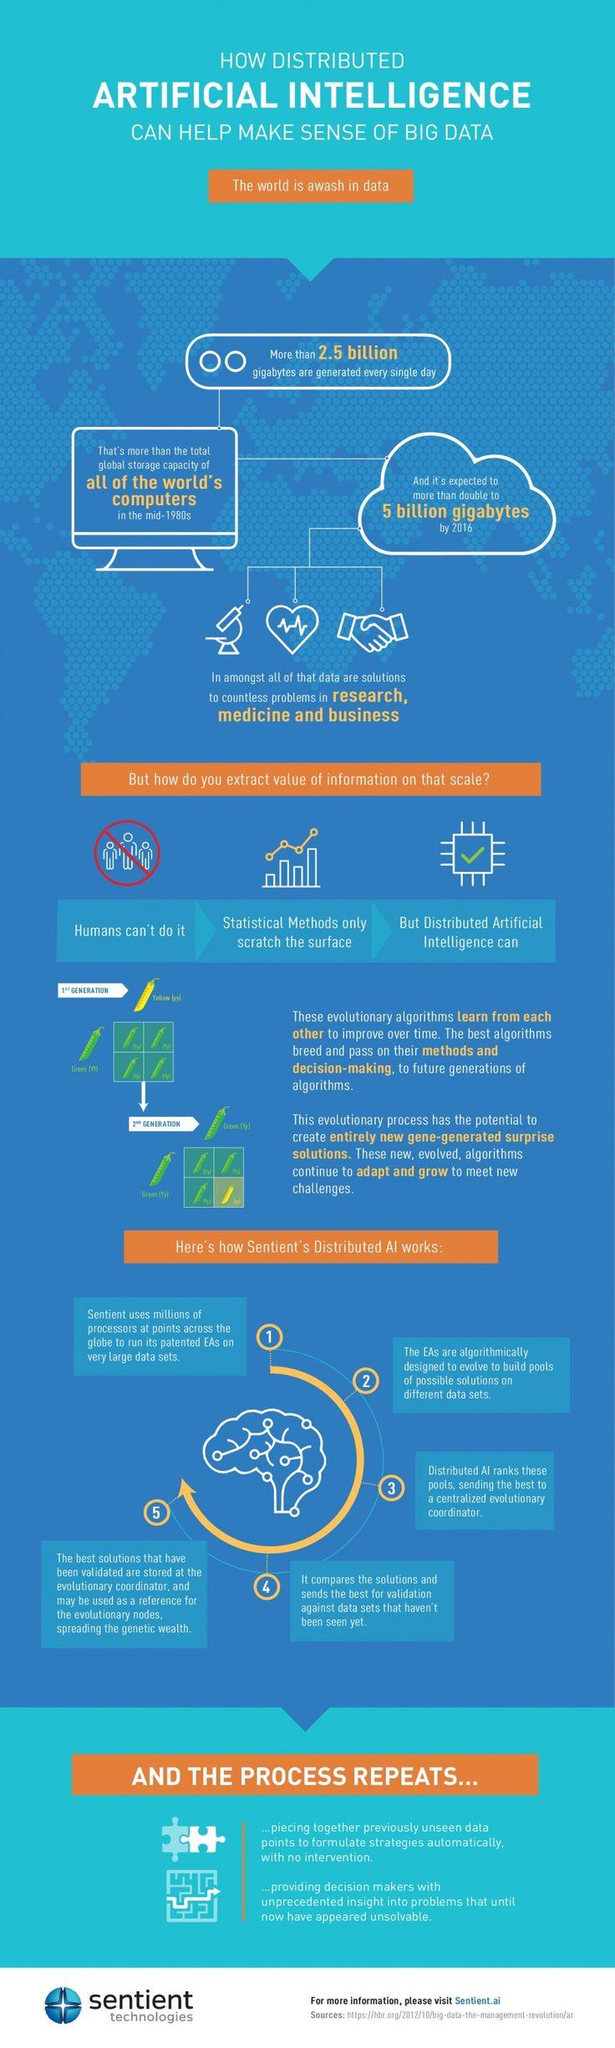Point out several critical features in this image. The most effective method for extracting valuable insights from information is through the use of distributed artificial intelligence. The Distributed AI sends the best of the ranked pools to a centralized evolutionary coordinator. 